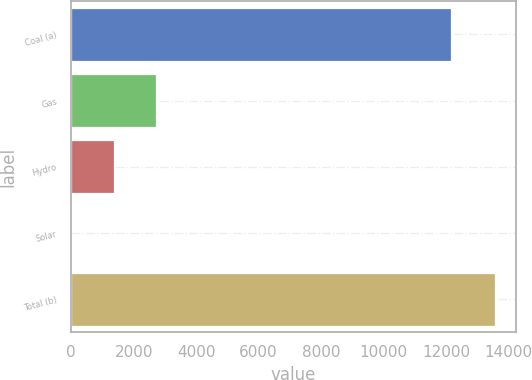<chart> <loc_0><loc_0><loc_500><loc_500><bar_chart><fcel>Coal (a)<fcel>Gas<fcel>Hydro<fcel>Solar<fcel>Total (b)<nl><fcel>12161<fcel>2715.8<fcel>1361.4<fcel>7<fcel>13551<nl></chart> 